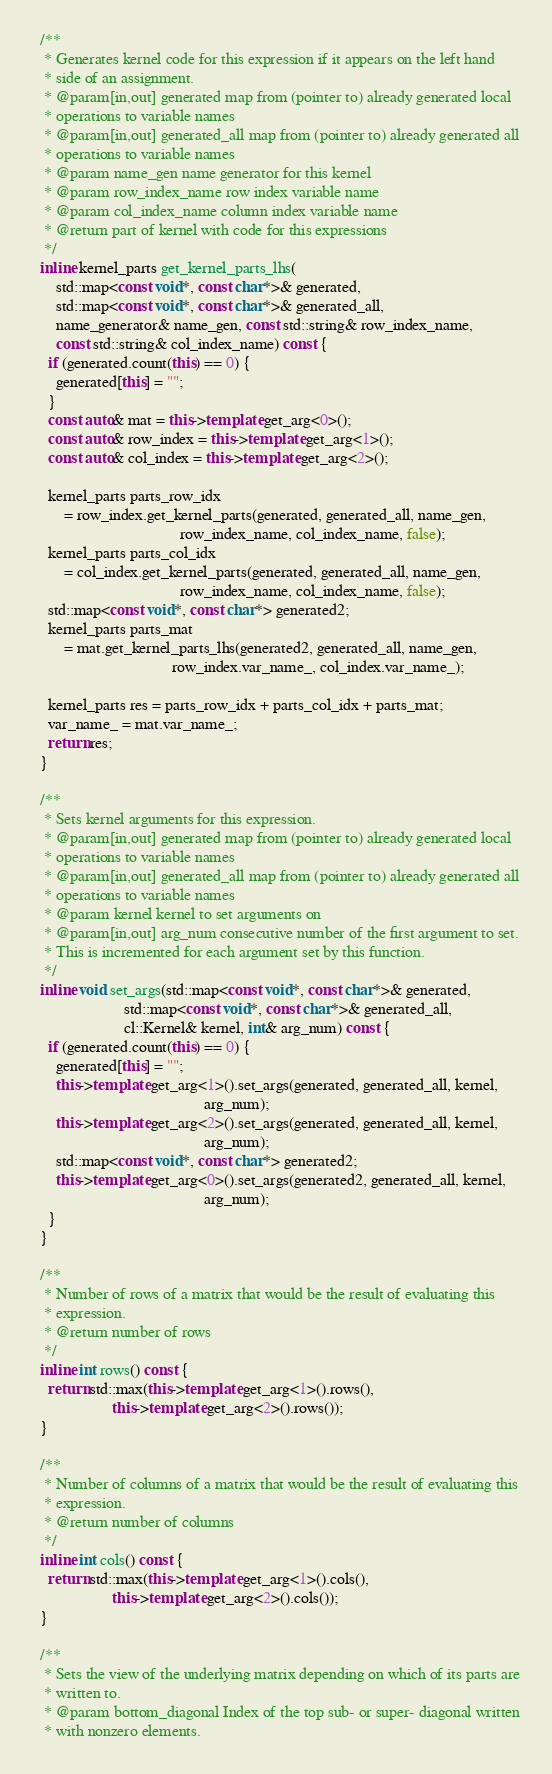Convert code to text. <code><loc_0><loc_0><loc_500><loc_500><_C++_>  /**
   * Generates kernel code for this expression if it appears on the left hand
   * side of an assignment.
   * @param[in,out] generated map from (pointer to) already generated local
   * operations to variable names
   * @param[in,out] generated_all map from (pointer to) already generated all
   * operations to variable names
   * @param name_gen name generator for this kernel
   * @param row_index_name row index variable name
   * @param col_index_name column index variable name
   * @return part of kernel with code for this expressions
   */
  inline kernel_parts get_kernel_parts_lhs(
      std::map<const void*, const char*>& generated,
      std::map<const void*, const char*>& generated_all,
      name_generator& name_gen, const std::string& row_index_name,
      const std::string& col_index_name) const {
    if (generated.count(this) == 0) {
      generated[this] = "";
    }
    const auto& mat = this->template get_arg<0>();
    const auto& row_index = this->template get_arg<1>();
    const auto& col_index = this->template get_arg<2>();

    kernel_parts parts_row_idx
        = row_index.get_kernel_parts(generated, generated_all, name_gen,
                                     row_index_name, col_index_name, false);
    kernel_parts parts_col_idx
        = col_index.get_kernel_parts(generated, generated_all, name_gen,
                                     row_index_name, col_index_name, false);
    std::map<const void*, const char*> generated2;
    kernel_parts parts_mat
        = mat.get_kernel_parts_lhs(generated2, generated_all, name_gen,
                                   row_index.var_name_, col_index.var_name_);

    kernel_parts res = parts_row_idx + parts_col_idx + parts_mat;
    var_name_ = mat.var_name_;
    return res;
  }

  /**
   * Sets kernel arguments for this expression.
   * @param[in,out] generated map from (pointer to) already generated local
   * operations to variable names
   * @param[in,out] generated_all map from (pointer to) already generated all
   * operations to variable names
   * @param kernel kernel to set arguments on
   * @param[in,out] arg_num consecutive number of the first argument to set.
   * This is incremented for each argument set by this function.
   */
  inline void set_args(std::map<const void*, const char*>& generated,
                       std::map<const void*, const char*>& generated_all,
                       cl::Kernel& kernel, int& arg_num) const {
    if (generated.count(this) == 0) {
      generated[this] = "";
      this->template get_arg<1>().set_args(generated, generated_all, kernel,
                                           arg_num);
      this->template get_arg<2>().set_args(generated, generated_all, kernel,
                                           arg_num);
      std::map<const void*, const char*> generated2;
      this->template get_arg<0>().set_args(generated2, generated_all, kernel,
                                           arg_num);
    }
  }

  /**
   * Number of rows of a matrix that would be the result of evaluating this
   * expression.
   * @return number of rows
   */
  inline int rows() const {
    return std::max(this->template get_arg<1>().rows(),
                    this->template get_arg<2>().rows());
  }

  /**
   * Number of columns of a matrix that would be the result of evaluating this
   * expression.
   * @return number of columns
   */
  inline int cols() const {
    return std::max(this->template get_arg<1>().cols(),
                    this->template get_arg<2>().cols());
  }

  /**
   * Sets the view of the underlying matrix depending on which of its parts are
   * written to.
   * @param bottom_diagonal Index of the top sub- or super- diagonal written
   * with nonzero elements.</code> 